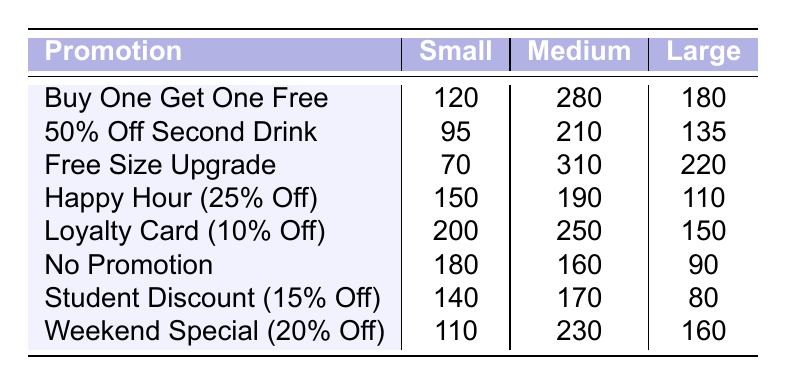What is the total number of small beverages ordered under the "Free Size Upgrade" promotion? According to the table, the "Free Size Upgrade" promotion shows that 70 small beverages were ordered.
Answer: 70 Which promotion had the highest number of medium beverage orders? In the table, the promotion "Free Size Upgrade" had the highest count of medium beverage orders at 310.
Answer: Free Size Upgrade What is the difference in the number of large beverages ordered between "Loyalty Card (10% Off)" and "No Promotion"? The count for "Loyalty Card (10% Off)" is 150 large beverages, while "No Promotion" has 90 large beverages. The difference is 150 - 90 = 60.
Answer: 60 How many small beverages were ordered in total across all promotions? Summing the small orders: 120 + 95 + 70 + 150 + 200 + 180 + 140 + 110 = 1,125 small beverages were ordered in total.
Answer: 1125 Was the number of medium beverages ordered under the "Happy Hour (25% Off)" promotion greater than under the "Student Discount (15% Off)" promotion? The "Happy Hour (25% Off)" had 190 medium beverages, while the "Student Discount (15% Off)" had 170. Since 190 is greater than 170, the answer is yes.
Answer: Yes What is the average number of large beverages ordered across all promotions? The total number of large beverages across promotions is 180 + 135 + 220 + 110 + 150 + 90 + 80 + 160 = 1,125. There are 8 promotions, so the average is 1,125 / 8 = 140.625.
Answer: 140.625 Which promotion had the least number of small beverages ordered? The "Free Size Upgrade" promotion shows the least number of small beverages ordered at 70.
Answer: Free Size Upgrade What promotion offered the maximum total number of beverages (small + medium + large) ordered? Calculating totals for each promotion: BOGOF = 580, 50% Off = 440, Free Upgrade = 600, Happy Hour = 450, Loyalty Card = 600, No Promotion = 430, Student Discount = 390, Weekend = 500. The maximum is from "Free Size Upgrade" and "Loyalty Card" at 600.
Answer: Free Size Upgrade, Loyalty Card Is it true that promotions affecting small beverage orders show a more significant variation compared to the large beverage orders? Small beverages range from 70 to 220 (variation of 150), whereas large beverages range from 80 to 220 (variation of 140). Thus, the statement is true.
Answer: True 